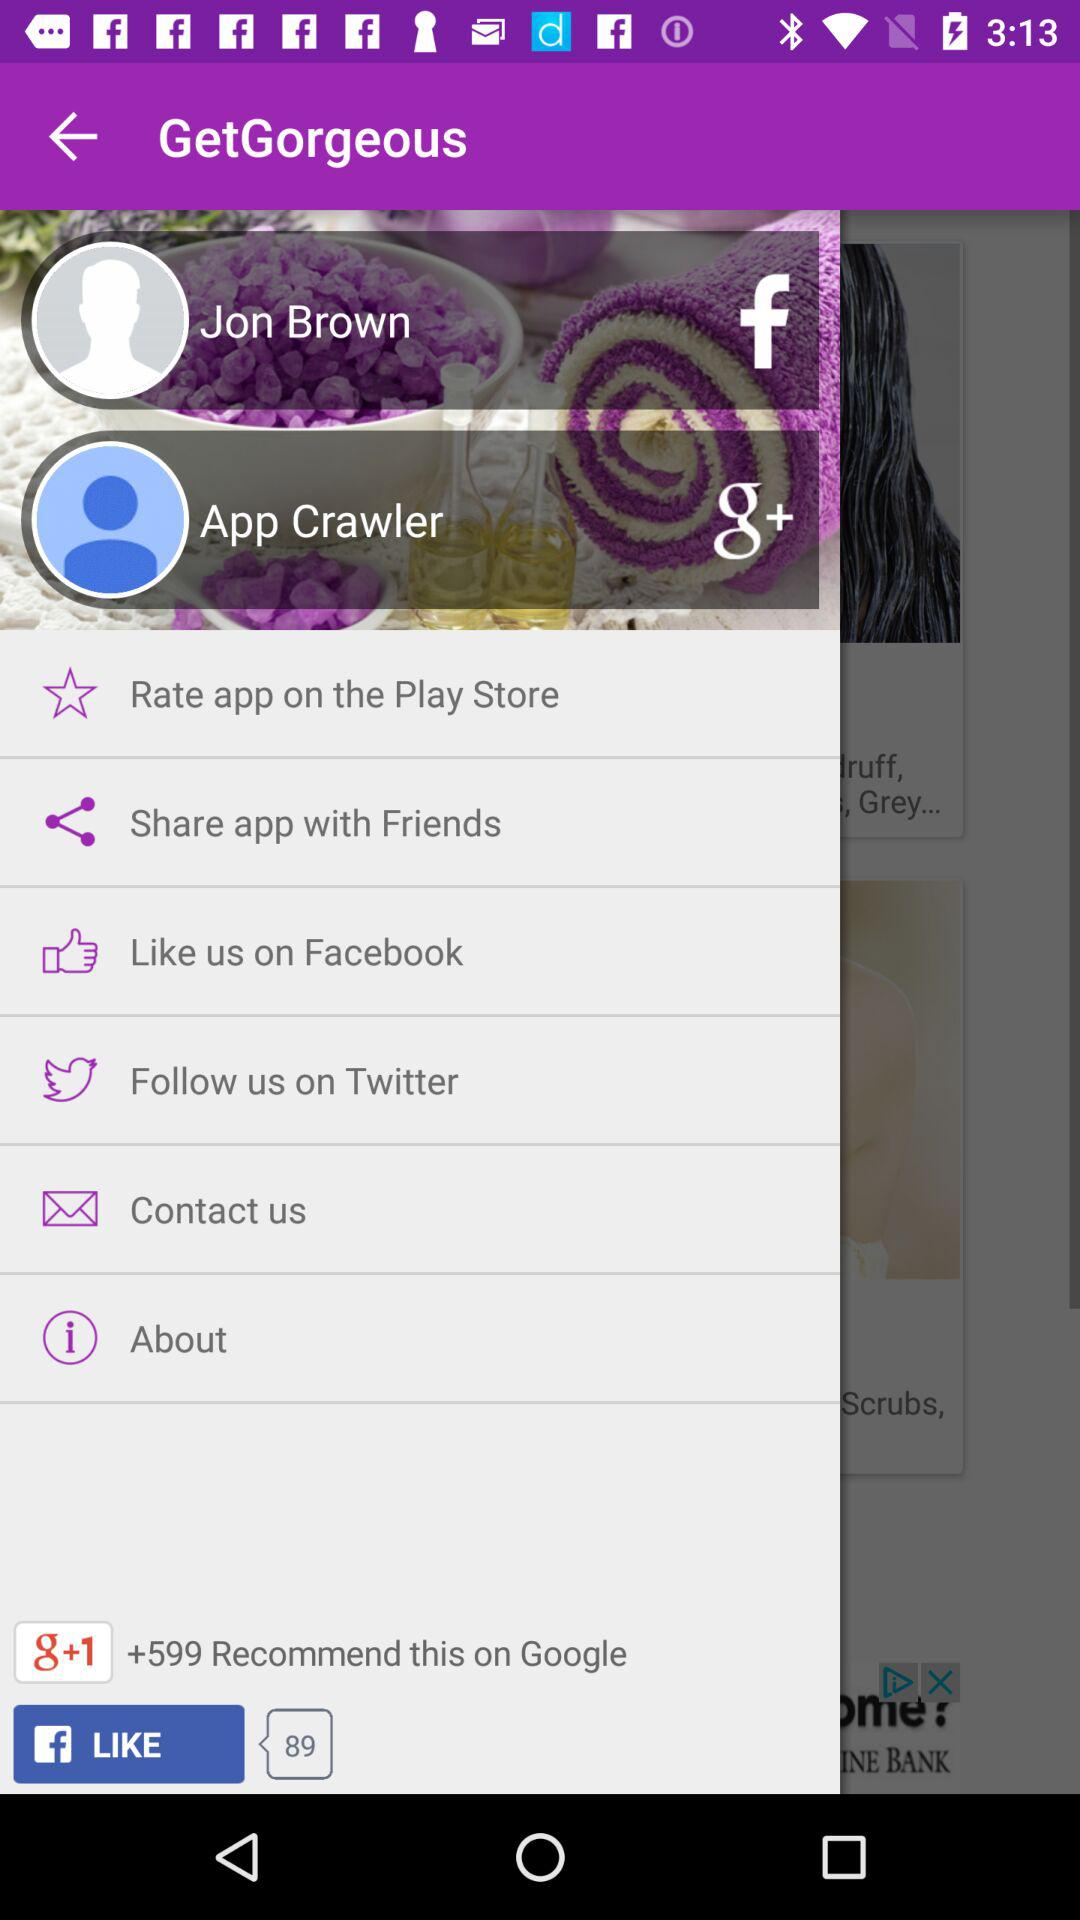How many people have recommended this on "Google"? The number of people who have recommended this on "Google" is +599. 